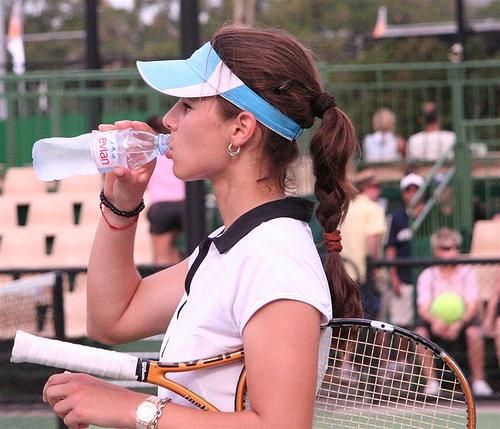Are there spectators?
Answer briefly. Yes. What brand of water is the woman drinking?
Quick response, please. Evian. What color hair tie is in her hair?
Answer briefly. Brown. 